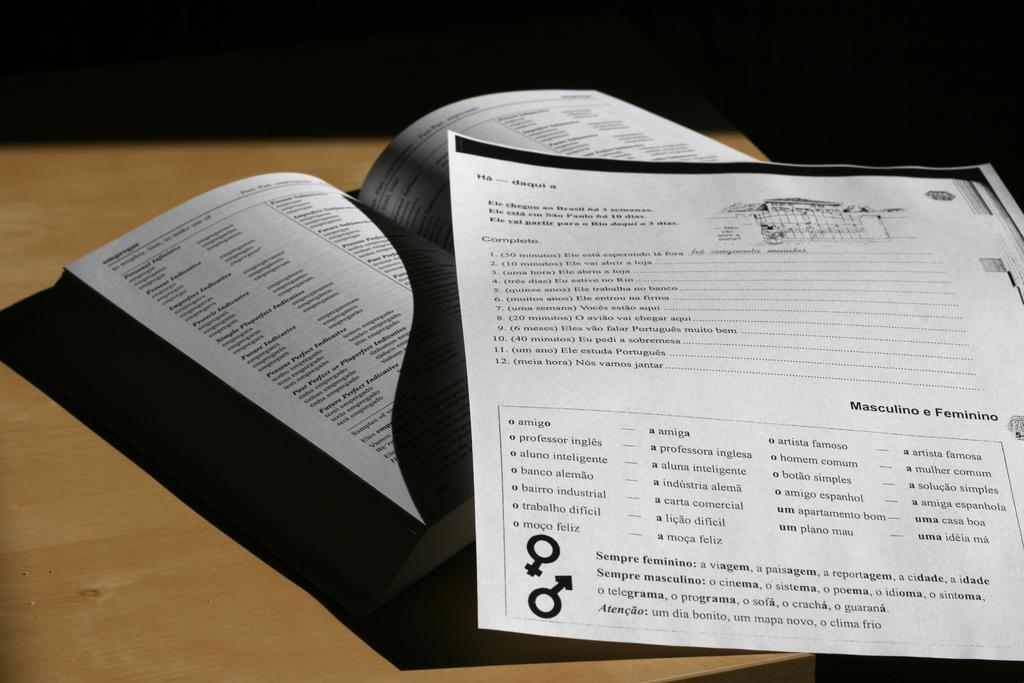<image>
Give a short and clear explanation of the subsequent image. An open Spanish workbook and page of homework explain the "Masculino e Feminino" words. 